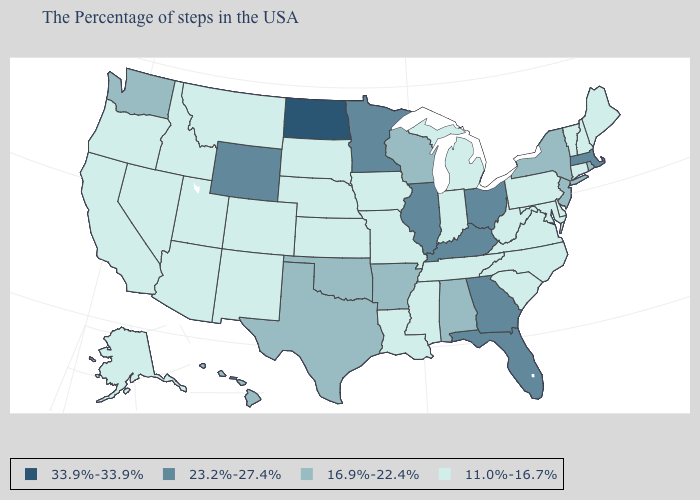Name the states that have a value in the range 16.9%-22.4%?
Answer briefly. Rhode Island, New York, New Jersey, Alabama, Wisconsin, Arkansas, Oklahoma, Texas, Washington, Hawaii. Name the states that have a value in the range 33.9%-33.9%?
Answer briefly. North Dakota. What is the highest value in the USA?
Short answer required. 33.9%-33.9%. What is the highest value in the USA?
Keep it brief. 33.9%-33.9%. Which states have the lowest value in the MidWest?
Be succinct. Michigan, Indiana, Missouri, Iowa, Kansas, Nebraska, South Dakota. What is the lowest value in states that border Nevada?
Quick response, please. 11.0%-16.7%. Name the states that have a value in the range 11.0%-16.7%?
Concise answer only. Maine, New Hampshire, Vermont, Connecticut, Delaware, Maryland, Pennsylvania, Virginia, North Carolina, South Carolina, West Virginia, Michigan, Indiana, Tennessee, Mississippi, Louisiana, Missouri, Iowa, Kansas, Nebraska, South Dakota, Colorado, New Mexico, Utah, Montana, Arizona, Idaho, Nevada, California, Oregon, Alaska. Does North Dakota have the highest value in the MidWest?
Answer briefly. Yes. Does the map have missing data?
Short answer required. No. Does the map have missing data?
Give a very brief answer. No. What is the value of Indiana?
Answer briefly. 11.0%-16.7%. What is the value of New Hampshire?
Answer briefly. 11.0%-16.7%. Does New York have the lowest value in the Northeast?
Quick response, please. No. 